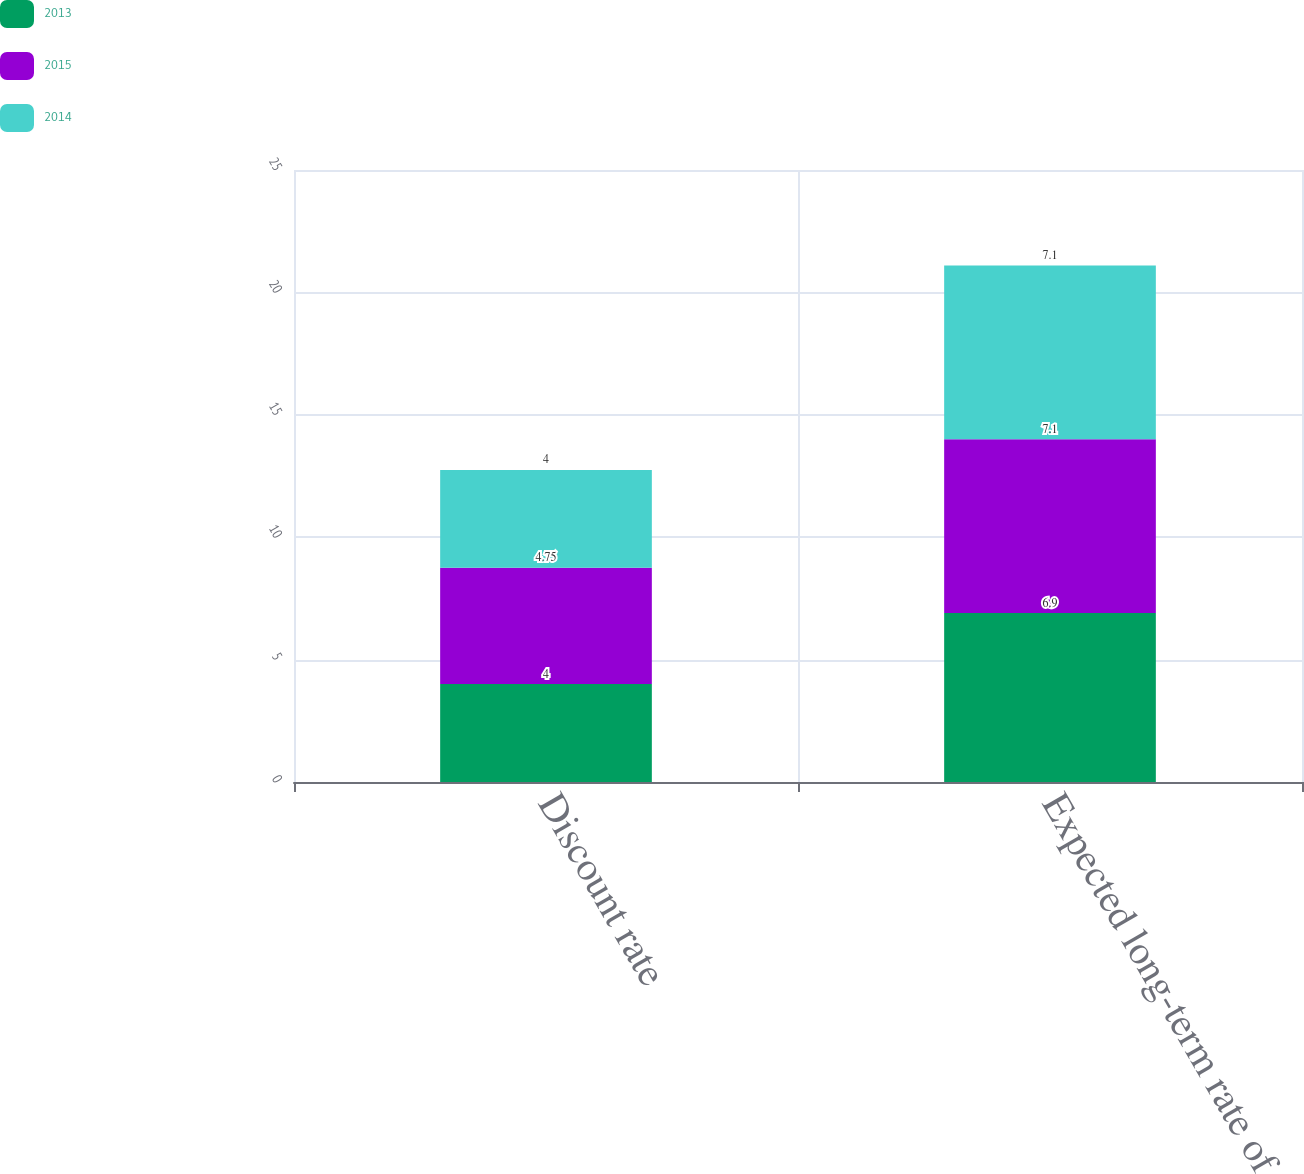Convert chart to OTSL. <chart><loc_0><loc_0><loc_500><loc_500><stacked_bar_chart><ecel><fcel>Discount rate<fcel>Expected long-term rate of<nl><fcel>2013<fcel>4<fcel>6.9<nl><fcel>2015<fcel>4.75<fcel>7.1<nl><fcel>2014<fcel>4<fcel>7.1<nl></chart> 